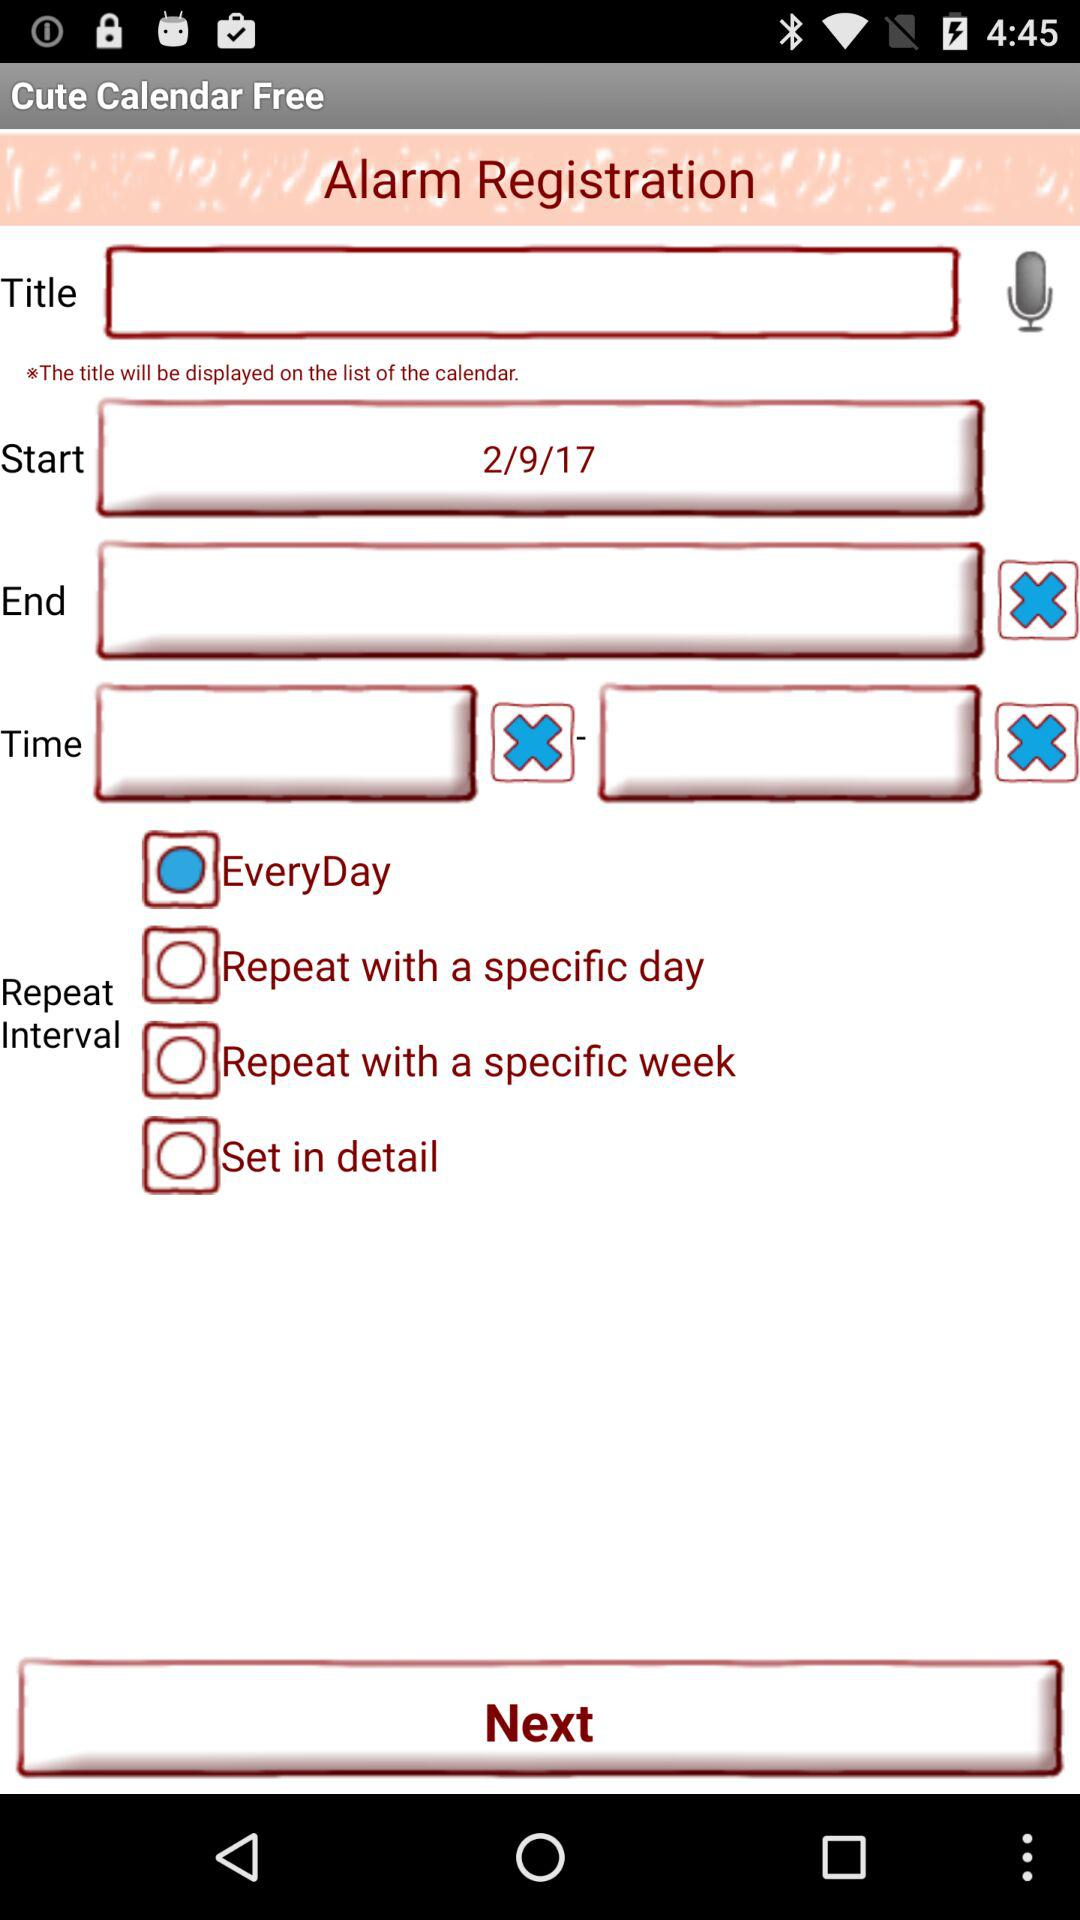What is the selected date to start? The selected date is 2/9/17. 